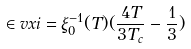Convert formula to latex. <formula><loc_0><loc_0><loc_500><loc_500>\in v x i = \xi _ { 0 } ^ { - 1 } ( T ) ( \frac { 4 T } { 3 T _ { c } } - \frac { 1 } { 3 } )</formula> 